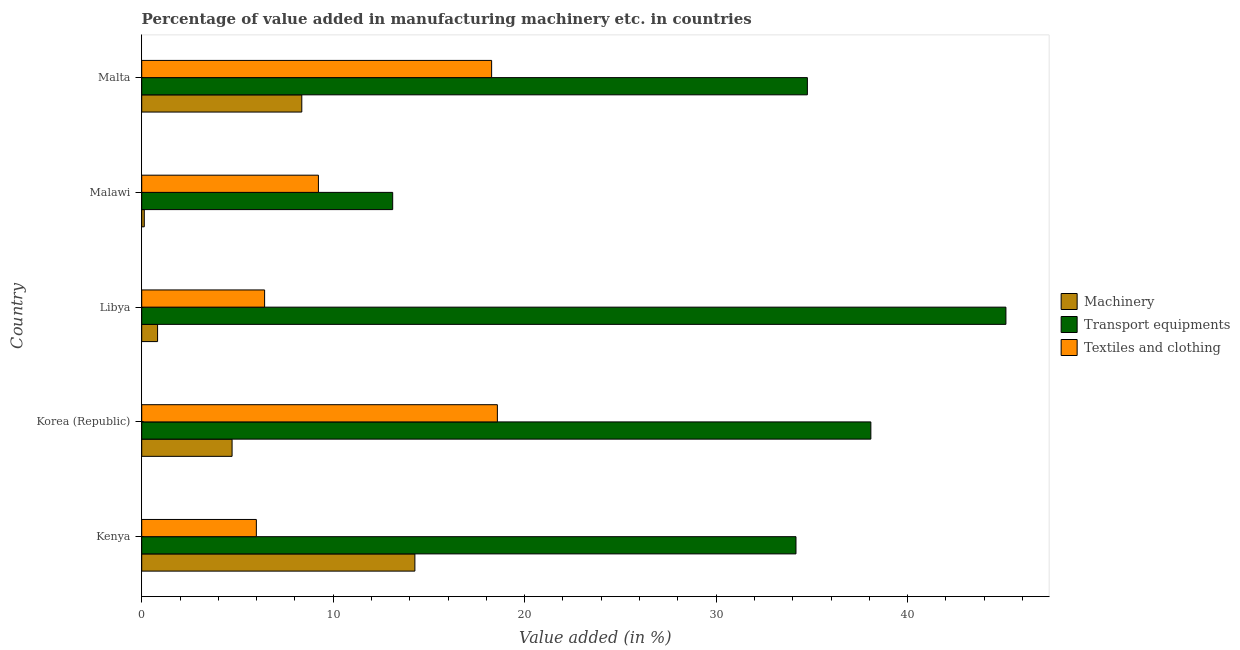How many different coloured bars are there?
Your answer should be compact. 3. How many bars are there on the 5th tick from the bottom?
Your answer should be very brief. 3. What is the label of the 3rd group of bars from the top?
Provide a succinct answer. Libya. What is the value added in manufacturing transport equipments in Malta?
Your answer should be compact. 34.77. Across all countries, what is the maximum value added in manufacturing machinery?
Your response must be concise. 14.27. Across all countries, what is the minimum value added in manufacturing textile and clothing?
Make the answer very short. 5.99. In which country was the value added in manufacturing machinery maximum?
Give a very brief answer. Kenya. In which country was the value added in manufacturing machinery minimum?
Offer a very short reply. Malawi. What is the total value added in manufacturing machinery in the graph?
Make the answer very short. 28.31. What is the difference between the value added in manufacturing textile and clothing in Kenya and that in Korea (Republic)?
Offer a terse response. -12.59. What is the difference between the value added in manufacturing textile and clothing in Malta and the value added in manufacturing transport equipments in Malawi?
Give a very brief answer. 5.17. What is the average value added in manufacturing machinery per country?
Keep it short and to the point. 5.66. What is the difference between the value added in manufacturing machinery and value added in manufacturing textile and clothing in Kenya?
Your response must be concise. 8.28. In how many countries, is the value added in manufacturing textile and clothing greater than 6 %?
Offer a terse response. 4. What is the ratio of the value added in manufacturing textile and clothing in Korea (Republic) to that in Malawi?
Make the answer very short. 2.01. Is the value added in manufacturing textile and clothing in Korea (Republic) less than that in Malawi?
Keep it short and to the point. No. Is the difference between the value added in manufacturing transport equipments in Kenya and Malawi greater than the difference between the value added in manufacturing textile and clothing in Kenya and Malawi?
Ensure brevity in your answer.  Yes. What is the difference between the highest and the second highest value added in manufacturing transport equipments?
Offer a very short reply. 7.05. What is the difference between the highest and the lowest value added in manufacturing machinery?
Make the answer very short. 14.13. What does the 3rd bar from the top in Korea (Republic) represents?
Provide a succinct answer. Machinery. What does the 3rd bar from the bottom in Libya represents?
Your answer should be very brief. Textiles and clothing. How many bars are there?
Give a very brief answer. 15. Where does the legend appear in the graph?
Ensure brevity in your answer.  Center right. How many legend labels are there?
Your answer should be compact. 3. What is the title of the graph?
Your response must be concise. Percentage of value added in manufacturing machinery etc. in countries. Does "Taxes on international trade" appear as one of the legend labels in the graph?
Ensure brevity in your answer.  No. What is the label or title of the X-axis?
Offer a very short reply. Value added (in %). What is the Value added (in %) of Machinery in Kenya?
Your response must be concise. 14.27. What is the Value added (in %) of Transport equipments in Kenya?
Keep it short and to the point. 34.17. What is the Value added (in %) of Textiles and clothing in Kenya?
Make the answer very short. 5.99. What is the Value added (in %) in Machinery in Korea (Republic)?
Your answer should be compact. 4.72. What is the Value added (in %) in Transport equipments in Korea (Republic)?
Make the answer very short. 38.08. What is the Value added (in %) in Textiles and clothing in Korea (Republic)?
Keep it short and to the point. 18.57. What is the Value added (in %) of Machinery in Libya?
Ensure brevity in your answer.  0.83. What is the Value added (in %) of Transport equipments in Libya?
Ensure brevity in your answer.  45.13. What is the Value added (in %) in Textiles and clothing in Libya?
Offer a very short reply. 6.42. What is the Value added (in %) of Machinery in Malawi?
Provide a succinct answer. 0.13. What is the Value added (in %) in Transport equipments in Malawi?
Keep it short and to the point. 13.11. What is the Value added (in %) of Textiles and clothing in Malawi?
Keep it short and to the point. 9.23. What is the Value added (in %) of Machinery in Malta?
Offer a terse response. 8.36. What is the Value added (in %) of Transport equipments in Malta?
Provide a succinct answer. 34.77. What is the Value added (in %) of Textiles and clothing in Malta?
Provide a short and direct response. 18.27. Across all countries, what is the maximum Value added (in %) of Machinery?
Your response must be concise. 14.27. Across all countries, what is the maximum Value added (in %) of Transport equipments?
Provide a short and direct response. 45.13. Across all countries, what is the maximum Value added (in %) of Textiles and clothing?
Your answer should be very brief. 18.57. Across all countries, what is the minimum Value added (in %) in Machinery?
Keep it short and to the point. 0.13. Across all countries, what is the minimum Value added (in %) of Transport equipments?
Offer a terse response. 13.11. Across all countries, what is the minimum Value added (in %) of Textiles and clothing?
Make the answer very short. 5.99. What is the total Value added (in %) in Machinery in the graph?
Your answer should be very brief. 28.31. What is the total Value added (in %) in Transport equipments in the graph?
Make the answer very short. 165.26. What is the total Value added (in %) in Textiles and clothing in the graph?
Offer a very short reply. 58.48. What is the difference between the Value added (in %) in Machinery in Kenya and that in Korea (Republic)?
Your answer should be very brief. 9.55. What is the difference between the Value added (in %) of Transport equipments in Kenya and that in Korea (Republic)?
Provide a succinct answer. -3.91. What is the difference between the Value added (in %) of Textiles and clothing in Kenya and that in Korea (Republic)?
Make the answer very short. -12.59. What is the difference between the Value added (in %) of Machinery in Kenya and that in Libya?
Your response must be concise. 13.44. What is the difference between the Value added (in %) of Transport equipments in Kenya and that in Libya?
Ensure brevity in your answer.  -10.96. What is the difference between the Value added (in %) in Textiles and clothing in Kenya and that in Libya?
Your response must be concise. -0.43. What is the difference between the Value added (in %) of Machinery in Kenya and that in Malawi?
Your response must be concise. 14.13. What is the difference between the Value added (in %) in Transport equipments in Kenya and that in Malawi?
Provide a short and direct response. 21.06. What is the difference between the Value added (in %) in Textiles and clothing in Kenya and that in Malawi?
Offer a very short reply. -3.24. What is the difference between the Value added (in %) in Machinery in Kenya and that in Malta?
Offer a very short reply. 5.91. What is the difference between the Value added (in %) of Transport equipments in Kenya and that in Malta?
Give a very brief answer. -0.6. What is the difference between the Value added (in %) of Textiles and clothing in Kenya and that in Malta?
Provide a succinct answer. -12.29. What is the difference between the Value added (in %) of Machinery in Korea (Republic) and that in Libya?
Offer a very short reply. 3.89. What is the difference between the Value added (in %) of Transport equipments in Korea (Republic) and that in Libya?
Provide a short and direct response. -7.05. What is the difference between the Value added (in %) in Textiles and clothing in Korea (Republic) and that in Libya?
Provide a short and direct response. 12.16. What is the difference between the Value added (in %) of Machinery in Korea (Republic) and that in Malawi?
Offer a terse response. 4.59. What is the difference between the Value added (in %) of Transport equipments in Korea (Republic) and that in Malawi?
Provide a short and direct response. 24.97. What is the difference between the Value added (in %) of Textiles and clothing in Korea (Republic) and that in Malawi?
Your answer should be very brief. 9.35. What is the difference between the Value added (in %) in Machinery in Korea (Republic) and that in Malta?
Ensure brevity in your answer.  -3.64. What is the difference between the Value added (in %) in Transport equipments in Korea (Republic) and that in Malta?
Provide a succinct answer. 3.32. What is the difference between the Value added (in %) in Textiles and clothing in Korea (Republic) and that in Malta?
Offer a terse response. 0.3. What is the difference between the Value added (in %) of Machinery in Libya and that in Malawi?
Ensure brevity in your answer.  0.69. What is the difference between the Value added (in %) in Transport equipments in Libya and that in Malawi?
Provide a short and direct response. 32.03. What is the difference between the Value added (in %) of Textiles and clothing in Libya and that in Malawi?
Provide a short and direct response. -2.81. What is the difference between the Value added (in %) in Machinery in Libya and that in Malta?
Your response must be concise. -7.53. What is the difference between the Value added (in %) of Transport equipments in Libya and that in Malta?
Offer a terse response. 10.37. What is the difference between the Value added (in %) in Textiles and clothing in Libya and that in Malta?
Make the answer very short. -11.86. What is the difference between the Value added (in %) of Machinery in Malawi and that in Malta?
Offer a terse response. -8.23. What is the difference between the Value added (in %) of Transport equipments in Malawi and that in Malta?
Give a very brief answer. -21.66. What is the difference between the Value added (in %) of Textiles and clothing in Malawi and that in Malta?
Give a very brief answer. -9.05. What is the difference between the Value added (in %) of Machinery in Kenya and the Value added (in %) of Transport equipments in Korea (Republic)?
Keep it short and to the point. -23.81. What is the difference between the Value added (in %) of Machinery in Kenya and the Value added (in %) of Textiles and clothing in Korea (Republic)?
Your answer should be compact. -4.31. What is the difference between the Value added (in %) in Transport equipments in Kenya and the Value added (in %) in Textiles and clothing in Korea (Republic)?
Offer a very short reply. 15.6. What is the difference between the Value added (in %) in Machinery in Kenya and the Value added (in %) in Transport equipments in Libya?
Make the answer very short. -30.87. What is the difference between the Value added (in %) of Machinery in Kenya and the Value added (in %) of Textiles and clothing in Libya?
Provide a succinct answer. 7.85. What is the difference between the Value added (in %) in Transport equipments in Kenya and the Value added (in %) in Textiles and clothing in Libya?
Offer a very short reply. 27.75. What is the difference between the Value added (in %) in Machinery in Kenya and the Value added (in %) in Transport equipments in Malawi?
Keep it short and to the point. 1.16. What is the difference between the Value added (in %) of Machinery in Kenya and the Value added (in %) of Textiles and clothing in Malawi?
Keep it short and to the point. 5.04. What is the difference between the Value added (in %) of Transport equipments in Kenya and the Value added (in %) of Textiles and clothing in Malawi?
Offer a terse response. 24.94. What is the difference between the Value added (in %) of Machinery in Kenya and the Value added (in %) of Transport equipments in Malta?
Your answer should be very brief. -20.5. What is the difference between the Value added (in %) of Machinery in Kenya and the Value added (in %) of Textiles and clothing in Malta?
Give a very brief answer. -4.01. What is the difference between the Value added (in %) in Transport equipments in Kenya and the Value added (in %) in Textiles and clothing in Malta?
Offer a terse response. 15.9. What is the difference between the Value added (in %) in Machinery in Korea (Republic) and the Value added (in %) in Transport equipments in Libya?
Make the answer very short. -40.42. What is the difference between the Value added (in %) in Machinery in Korea (Republic) and the Value added (in %) in Textiles and clothing in Libya?
Offer a terse response. -1.7. What is the difference between the Value added (in %) of Transport equipments in Korea (Republic) and the Value added (in %) of Textiles and clothing in Libya?
Offer a very short reply. 31.66. What is the difference between the Value added (in %) of Machinery in Korea (Republic) and the Value added (in %) of Transport equipments in Malawi?
Your response must be concise. -8.39. What is the difference between the Value added (in %) of Machinery in Korea (Republic) and the Value added (in %) of Textiles and clothing in Malawi?
Keep it short and to the point. -4.51. What is the difference between the Value added (in %) of Transport equipments in Korea (Republic) and the Value added (in %) of Textiles and clothing in Malawi?
Keep it short and to the point. 28.85. What is the difference between the Value added (in %) in Machinery in Korea (Republic) and the Value added (in %) in Transport equipments in Malta?
Make the answer very short. -30.05. What is the difference between the Value added (in %) in Machinery in Korea (Republic) and the Value added (in %) in Textiles and clothing in Malta?
Ensure brevity in your answer.  -13.56. What is the difference between the Value added (in %) of Transport equipments in Korea (Republic) and the Value added (in %) of Textiles and clothing in Malta?
Ensure brevity in your answer.  19.81. What is the difference between the Value added (in %) of Machinery in Libya and the Value added (in %) of Transport equipments in Malawi?
Your response must be concise. -12.28. What is the difference between the Value added (in %) of Machinery in Libya and the Value added (in %) of Textiles and clothing in Malawi?
Offer a very short reply. -8.4. What is the difference between the Value added (in %) of Transport equipments in Libya and the Value added (in %) of Textiles and clothing in Malawi?
Your answer should be compact. 35.91. What is the difference between the Value added (in %) of Machinery in Libya and the Value added (in %) of Transport equipments in Malta?
Offer a terse response. -33.94. What is the difference between the Value added (in %) in Machinery in Libya and the Value added (in %) in Textiles and clothing in Malta?
Your response must be concise. -17.45. What is the difference between the Value added (in %) of Transport equipments in Libya and the Value added (in %) of Textiles and clothing in Malta?
Keep it short and to the point. 26.86. What is the difference between the Value added (in %) in Machinery in Malawi and the Value added (in %) in Transport equipments in Malta?
Your response must be concise. -34.63. What is the difference between the Value added (in %) in Machinery in Malawi and the Value added (in %) in Textiles and clothing in Malta?
Your answer should be compact. -18.14. What is the difference between the Value added (in %) in Transport equipments in Malawi and the Value added (in %) in Textiles and clothing in Malta?
Keep it short and to the point. -5.17. What is the average Value added (in %) of Machinery per country?
Your answer should be very brief. 5.66. What is the average Value added (in %) of Transport equipments per country?
Provide a short and direct response. 33.05. What is the average Value added (in %) in Textiles and clothing per country?
Give a very brief answer. 11.7. What is the difference between the Value added (in %) in Machinery and Value added (in %) in Transport equipments in Kenya?
Your answer should be very brief. -19.9. What is the difference between the Value added (in %) of Machinery and Value added (in %) of Textiles and clothing in Kenya?
Make the answer very short. 8.28. What is the difference between the Value added (in %) of Transport equipments and Value added (in %) of Textiles and clothing in Kenya?
Your answer should be very brief. 28.18. What is the difference between the Value added (in %) in Machinery and Value added (in %) in Transport equipments in Korea (Republic)?
Your response must be concise. -33.36. What is the difference between the Value added (in %) of Machinery and Value added (in %) of Textiles and clothing in Korea (Republic)?
Ensure brevity in your answer.  -13.86. What is the difference between the Value added (in %) of Transport equipments and Value added (in %) of Textiles and clothing in Korea (Republic)?
Offer a very short reply. 19.51. What is the difference between the Value added (in %) in Machinery and Value added (in %) in Transport equipments in Libya?
Offer a very short reply. -44.31. What is the difference between the Value added (in %) in Machinery and Value added (in %) in Textiles and clothing in Libya?
Offer a very short reply. -5.59. What is the difference between the Value added (in %) in Transport equipments and Value added (in %) in Textiles and clothing in Libya?
Offer a very short reply. 38.72. What is the difference between the Value added (in %) in Machinery and Value added (in %) in Transport equipments in Malawi?
Provide a short and direct response. -12.97. What is the difference between the Value added (in %) in Machinery and Value added (in %) in Textiles and clothing in Malawi?
Provide a succinct answer. -9.1. What is the difference between the Value added (in %) in Transport equipments and Value added (in %) in Textiles and clothing in Malawi?
Your answer should be very brief. 3.88. What is the difference between the Value added (in %) of Machinery and Value added (in %) of Transport equipments in Malta?
Make the answer very short. -26.4. What is the difference between the Value added (in %) in Machinery and Value added (in %) in Textiles and clothing in Malta?
Your answer should be compact. -9.91. What is the difference between the Value added (in %) of Transport equipments and Value added (in %) of Textiles and clothing in Malta?
Make the answer very short. 16.49. What is the ratio of the Value added (in %) of Machinery in Kenya to that in Korea (Republic)?
Give a very brief answer. 3.02. What is the ratio of the Value added (in %) of Transport equipments in Kenya to that in Korea (Republic)?
Your answer should be compact. 0.9. What is the ratio of the Value added (in %) in Textiles and clothing in Kenya to that in Korea (Republic)?
Provide a succinct answer. 0.32. What is the ratio of the Value added (in %) in Machinery in Kenya to that in Libya?
Give a very brief answer. 17.23. What is the ratio of the Value added (in %) in Transport equipments in Kenya to that in Libya?
Provide a succinct answer. 0.76. What is the ratio of the Value added (in %) in Textiles and clothing in Kenya to that in Libya?
Your answer should be compact. 0.93. What is the ratio of the Value added (in %) in Machinery in Kenya to that in Malawi?
Offer a terse response. 106.67. What is the ratio of the Value added (in %) in Transport equipments in Kenya to that in Malawi?
Ensure brevity in your answer.  2.61. What is the ratio of the Value added (in %) in Textiles and clothing in Kenya to that in Malawi?
Offer a terse response. 0.65. What is the ratio of the Value added (in %) of Machinery in Kenya to that in Malta?
Ensure brevity in your answer.  1.71. What is the ratio of the Value added (in %) in Transport equipments in Kenya to that in Malta?
Offer a terse response. 0.98. What is the ratio of the Value added (in %) in Textiles and clothing in Kenya to that in Malta?
Your answer should be very brief. 0.33. What is the ratio of the Value added (in %) in Machinery in Korea (Republic) to that in Libya?
Your answer should be very brief. 5.7. What is the ratio of the Value added (in %) of Transport equipments in Korea (Republic) to that in Libya?
Give a very brief answer. 0.84. What is the ratio of the Value added (in %) in Textiles and clothing in Korea (Republic) to that in Libya?
Your answer should be very brief. 2.89. What is the ratio of the Value added (in %) of Machinery in Korea (Republic) to that in Malawi?
Keep it short and to the point. 35.28. What is the ratio of the Value added (in %) of Transport equipments in Korea (Republic) to that in Malawi?
Keep it short and to the point. 2.91. What is the ratio of the Value added (in %) of Textiles and clothing in Korea (Republic) to that in Malawi?
Offer a very short reply. 2.01. What is the ratio of the Value added (in %) in Machinery in Korea (Republic) to that in Malta?
Your answer should be very brief. 0.56. What is the ratio of the Value added (in %) of Transport equipments in Korea (Republic) to that in Malta?
Ensure brevity in your answer.  1.1. What is the ratio of the Value added (in %) in Textiles and clothing in Korea (Republic) to that in Malta?
Offer a terse response. 1.02. What is the ratio of the Value added (in %) in Machinery in Libya to that in Malawi?
Keep it short and to the point. 6.19. What is the ratio of the Value added (in %) of Transport equipments in Libya to that in Malawi?
Offer a very short reply. 3.44. What is the ratio of the Value added (in %) of Textiles and clothing in Libya to that in Malawi?
Your response must be concise. 0.7. What is the ratio of the Value added (in %) in Machinery in Libya to that in Malta?
Your answer should be very brief. 0.1. What is the ratio of the Value added (in %) in Transport equipments in Libya to that in Malta?
Your answer should be very brief. 1.3. What is the ratio of the Value added (in %) in Textiles and clothing in Libya to that in Malta?
Ensure brevity in your answer.  0.35. What is the ratio of the Value added (in %) in Machinery in Malawi to that in Malta?
Your answer should be compact. 0.02. What is the ratio of the Value added (in %) in Transport equipments in Malawi to that in Malta?
Offer a terse response. 0.38. What is the ratio of the Value added (in %) of Textiles and clothing in Malawi to that in Malta?
Your answer should be very brief. 0.51. What is the difference between the highest and the second highest Value added (in %) of Machinery?
Your response must be concise. 5.91. What is the difference between the highest and the second highest Value added (in %) in Transport equipments?
Provide a short and direct response. 7.05. What is the difference between the highest and the second highest Value added (in %) in Textiles and clothing?
Provide a short and direct response. 0.3. What is the difference between the highest and the lowest Value added (in %) in Machinery?
Keep it short and to the point. 14.13. What is the difference between the highest and the lowest Value added (in %) of Transport equipments?
Give a very brief answer. 32.03. What is the difference between the highest and the lowest Value added (in %) in Textiles and clothing?
Make the answer very short. 12.59. 